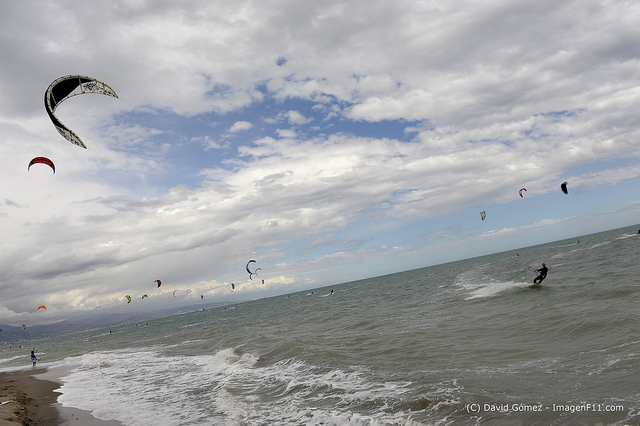Identify the text contained in this image. David Gomez Imagen nF11.com (C) 